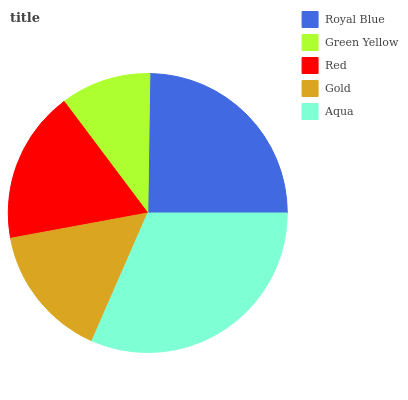Is Green Yellow the minimum?
Answer yes or no. Yes. Is Aqua the maximum?
Answer yes or no. Yes. Is Red the minimum?
Answer yes or no. No. Is Red the maximum?
Answer yes or no. No. Is Red greater than Green Yellow?
Answer yes or no. Yes. Is Green Yellow less than Red?
Answer yes or no. Yes. Is Green Yellow greater than Red?
Answer yes or no. No. Is Red less than Green Yellow?
Answer yes or no. No. Is Red the high median?
Answer yes or no. Yes. Is Red the low median?
Answer yes or no. Yes. Is Royal Blue the high median?
Answer yes or no. No. Is Aqua the low median?
Answer yes or no. No. 